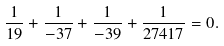<formula> <loc_0><loc_0><loc_500><loc_500>\frac { 1 } { 1 9 } + \frac { 1 } { - 3 7 } + \frac { 1 } { - 3 9 } + \frac { 1 } { 2 7 4 1 7 } = 0 .</formula> 